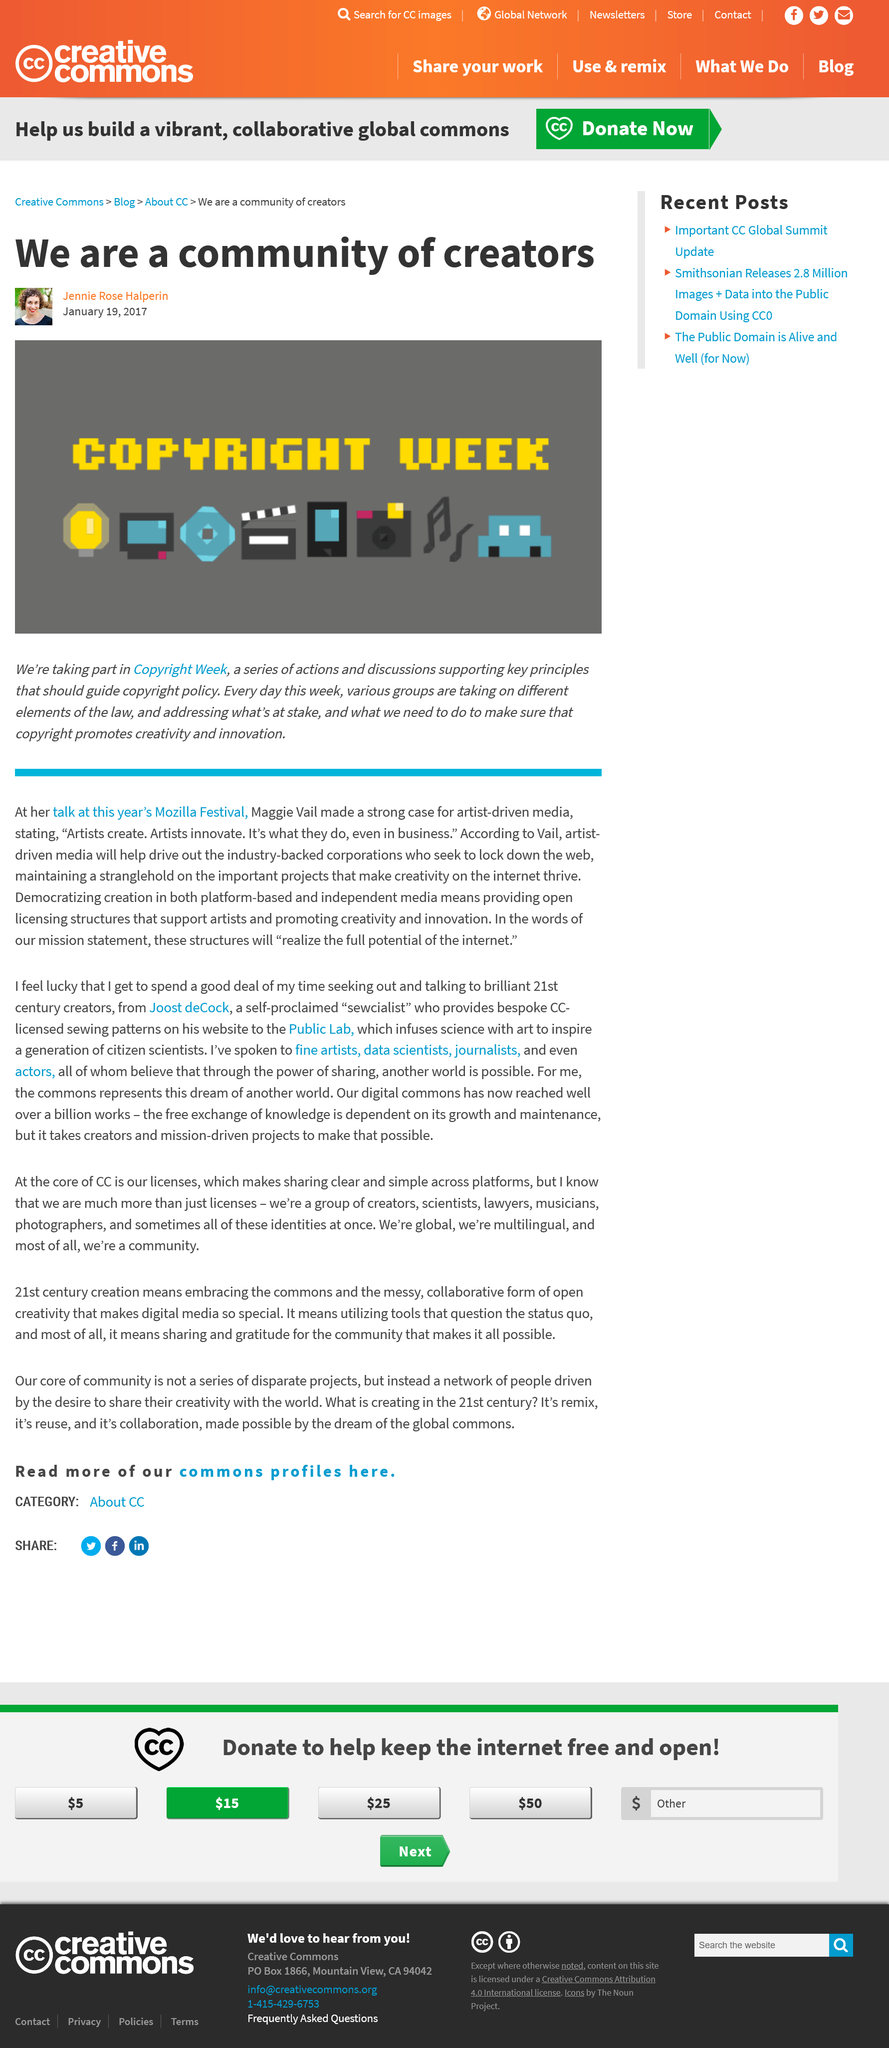Outline some significant characteristics in this image. Eight different media types are represented in the data provided. The article refers to Copyright Week in the year 2017. Copyright should promote creativity and innovation by encouraging the creation and distribution of original works. 